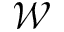<formula> <loc_0><loc_0><loc_500><loc_500>\mathcal { W }</formula> 